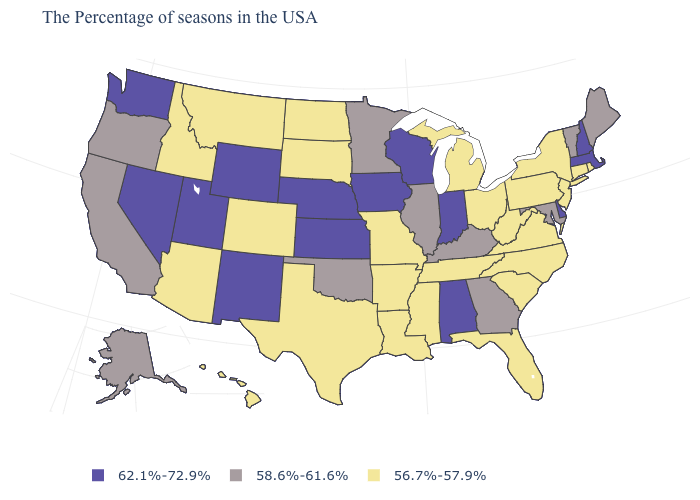Does Vermont have a higher value than Maryland?
Quick response, please. No. What is the value of New Hampshire?
Be succinct. 62.1%-72.9%. What is the value of New Jersey?
Give a very brief answer. 56.7%-57.9%. Does North Carolina have the lowest value in the South?
Quick response, please. Yes. Name the states that have a value in the range 58.6%-61.6%?
Write a very short answer. Maine, Vermont, Maryland, Georgia, Kentucky, Illinois, Minnesota, Oklahoma, California, Oregon, Alaska. Which states hav the highest value in the MidWest?
Write a very short answer. Indiana, Wisconsin, Iowa, Kansas, Nebraska. Name the states that have a value in the range 58.6%-61.6%?
Answer briefly. Maine, Vermont, Maryland, Georgia, Kentucky, Illinois, Minnesota, Oklahoma, California, Oregon, Alaska. What is the highest value in the USA?
Answer briefly. 62.1%-72.9%. Is the legend a continuous bar?
Short answer required. No. Among the states that border New York , which have the lowest value?
Keep it brief. Connecticut, New Jersey, Pennsylvania. What is the value of Maine?
Quick response, please. 58.6%-61.6%. Name the states that have a value in the range 56.7%-57.9%?
Be succinct. Rhode Island, Connecticut, New York, New Jersey, Pennsylvania, Virginia, North Carolina, South Carolina, West Virginia, Ohio, Florida, Michigan, Tennessee, Mississippi, Louisiana, Missouri, Arkansas, Texas, South Dakota, North Dakota, Colorado, Montana, Arizona, Idaho, Hawaii. What is the lowest value in states that border South Dakota?
Be succinct. 56.7%-57.9%. What is the value of Florida?
Write a very short answer. 56.7%-57.9%. 